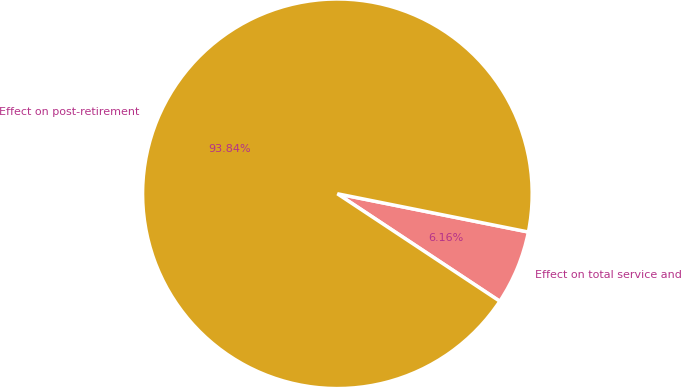<chart> <loc_0><loc_0><loc_500><loc_500><pie_chart><fcel>Effect on total service and<fcel>Effect on post-retirement<nl><fcel>6.16%<fcel>93.84%<nl></chart> 